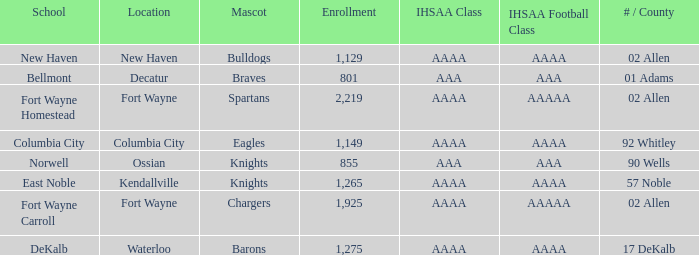What's the enrollment for Kendallville? 1265.0. 